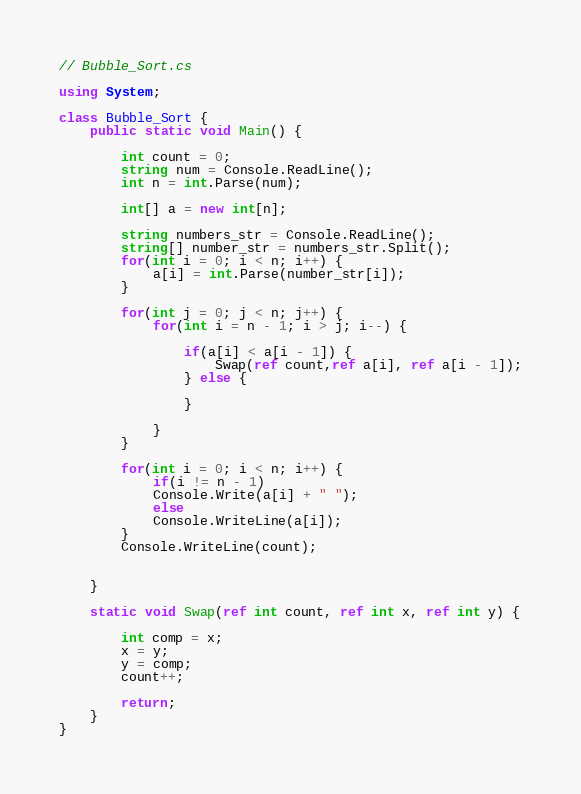<code> <loc_0><loc_0><loc_500><loc_500><_C#_>// Bubble_Sort.cs

using System;

class Bubble_Sort {
	public static void Main() {

		int count = 0;
		string num = Console.ReadLine();
		int n = int.Parse(num);

		int[] a = new int[n];

		string numbers_str = Console.ReadLine();
		string[] number_str = numbers_str.Split();
		for(int i = 0; i < n; i++) {
			a[i] = int.Parse(number_str[i]);
		}

		for(int j = 0; j < n; j++) {
			for(int i = n - 1; i > j; i--) {

				if(a[i] < a[i - 1]) {
					Swap(ref count,ref a[i], ref a[i - 1]);
				} else {
			
				}

			}
		}

		for(int i = 0; i < n; i++) {
			if(i != n - 1)
			Console.Write(a[i] + " ");
			else
			Console.WriteLine(a[i]);
		}
		Console.WriteLine(count);


	}

	static void Swap(ref int count, ref int x, ref int y) {

		int comp = x;
		x = y;
		y = comp;
		count++;

		return;
	}
}</code> 